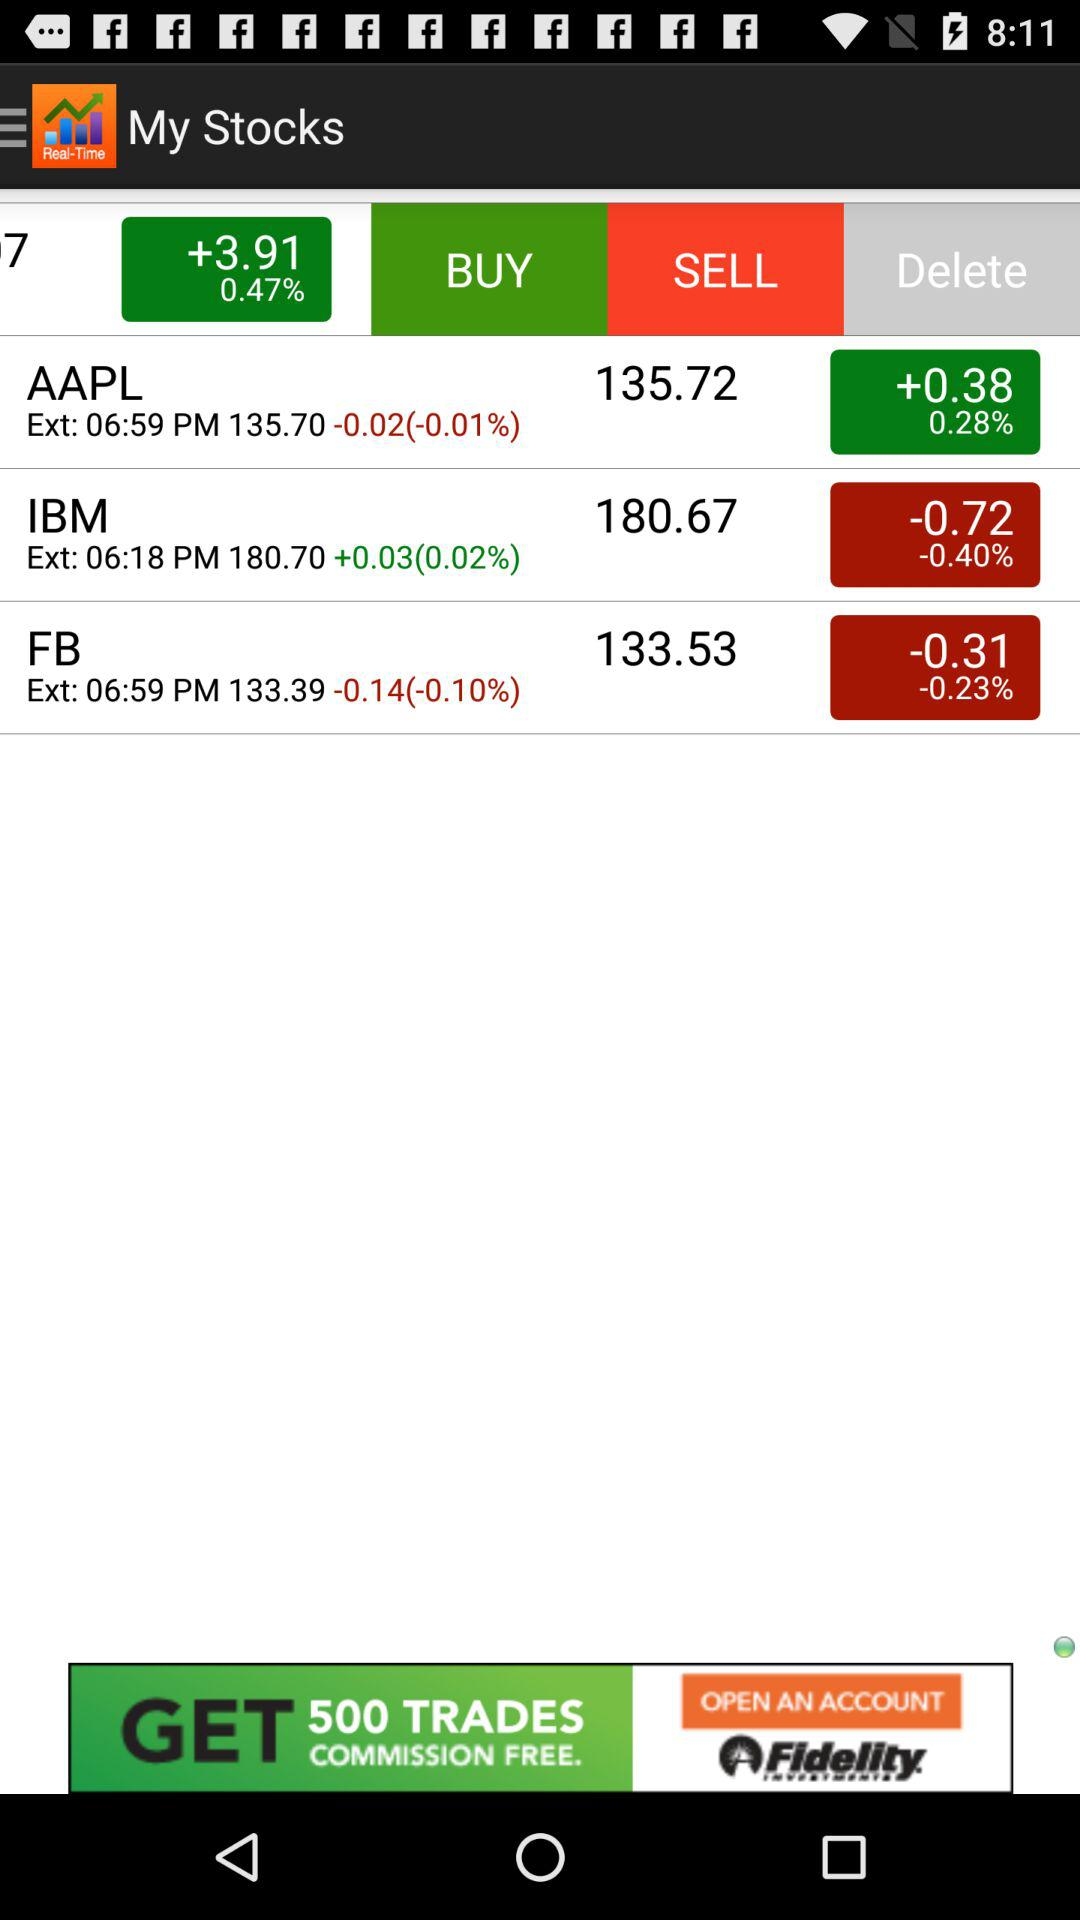What is the difference between the current price and the extended price for IBM?
Answer the question using a single word or phrase. 0.03 